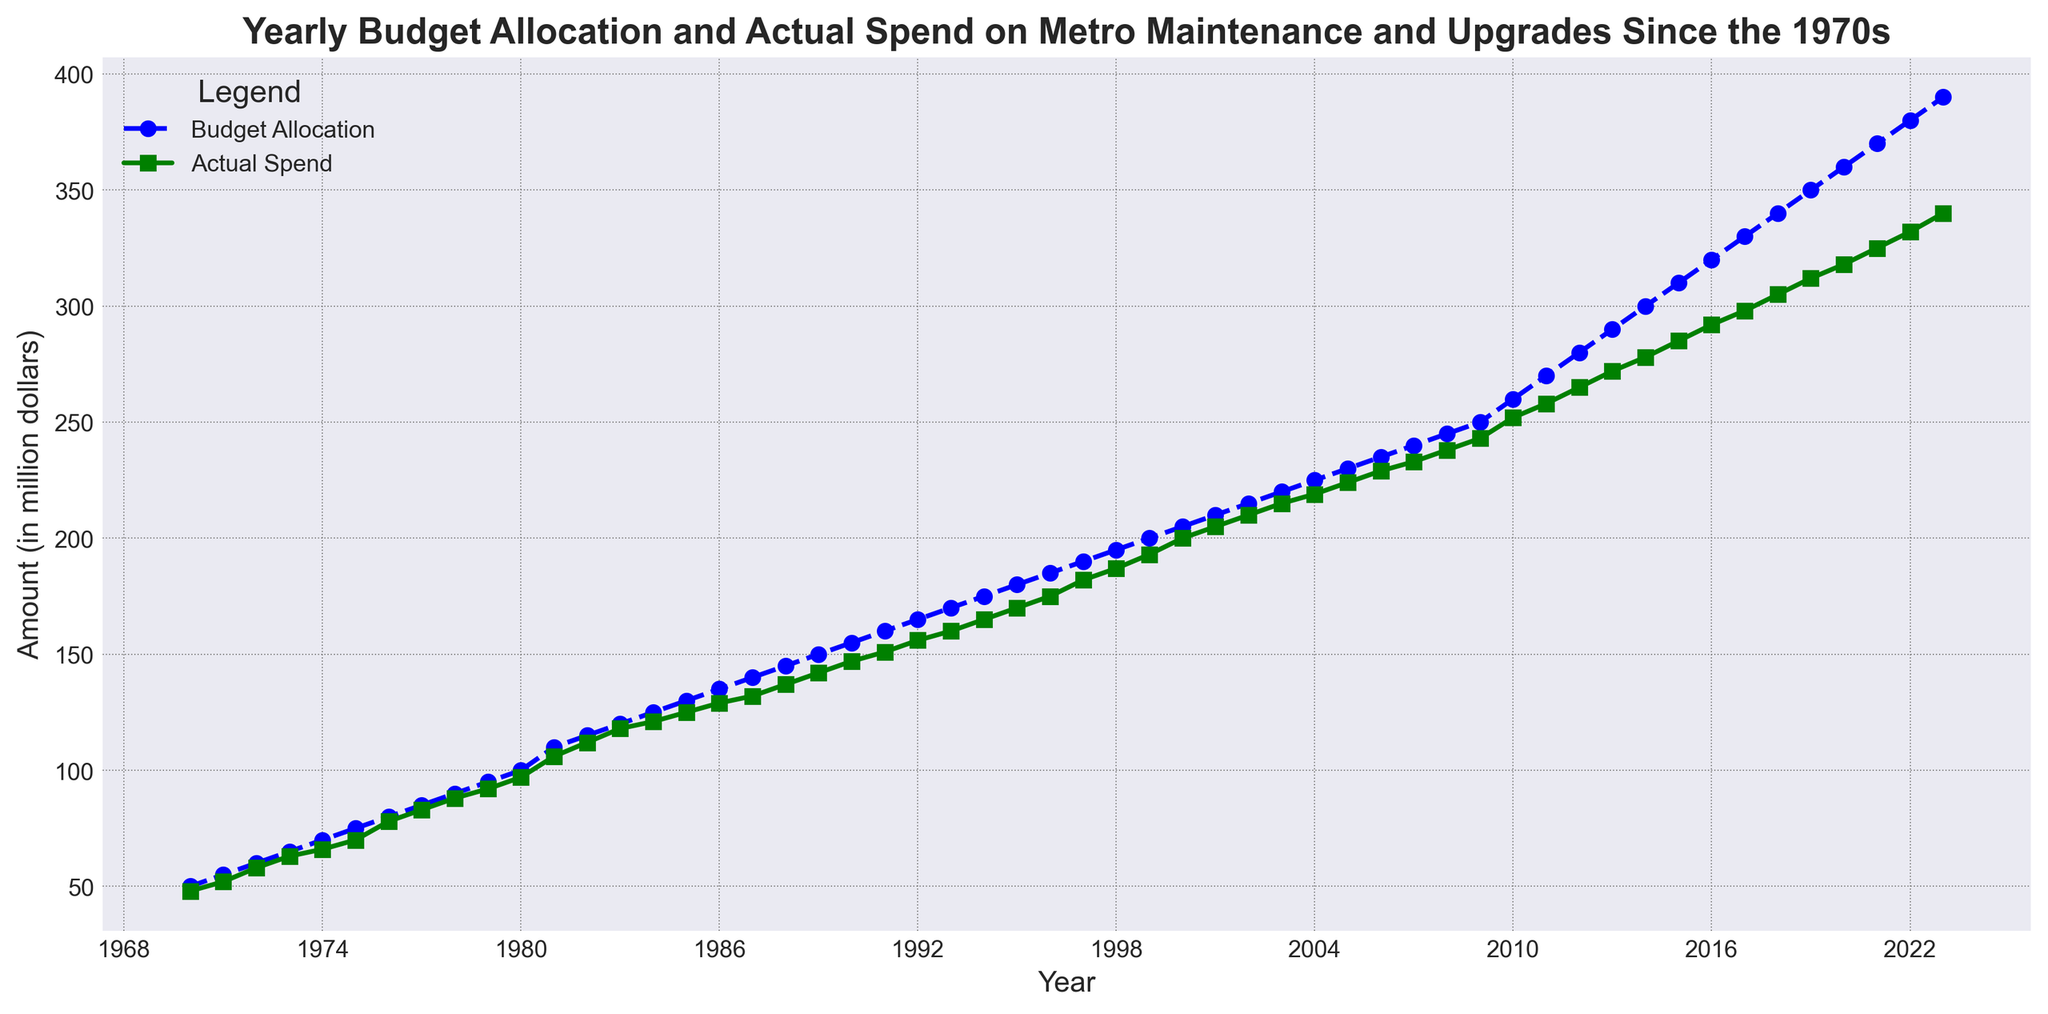What is the trend of Budget Allocation from 1970 to 2023? The Budget Allocation shows a steady increasing trend from 50 million dollars in 1970 to 390 million dollars in 2023.
Answer: Increasing How often did the Actual Spend exceed the Budget Allocation? By observing the lines on the plot, we can see that the Actual Spend consistently falls below the Budget Allocation throughout the entire period from 1970 to 2023.
Answer: Never What is the difference between Budget Allocation and Actual Spend in 1980? From the figure, the Budget Allocation in 1980 is 100 million dollars, and the Actual Spend is 97 million dollars. The difference is 100 - 97.
Answer: 3 million dollars Which year had the largest gap between Budget Allocation and Actual Spend? By visually inspecting the gap between the two curves, 2023 shows the largest gap. The Budget Allocation in 2023 is 390 million dollars, and Actual Spend is 340 million dollars. The difference is 390 - 340.
Answer: 2023 What is the average Actual Spend between 2000 and 2010? Add the Actual Spend from 2000 to 2010: (200 + 205 + 210 + 215 + 219 + 224 + 229 + 233 + 238 + 243 + 252), which equals 2268, then divide by the number of years, which is 11.
Answer: 206.18 million dollars How does the rate of increase in Actual Spend compare to Budget Allocation from 2015 to 2020? To compare the rates:
Rate of increase for Budget Allocation: (360 - 310) / 310 = 0.161, or 16.1%
Rate of increase for Actual Spend: (318 - 285) / 285 = 0.1158, or 11.58% 
Hence, the Budget Allocation has a higher rate of increase than Actual Spend.
Answer: Budget Allocation increases faster By how much did the Budget Allocation increase from the year 1990 to the year 2000? The Budget Allocation in 1990 is 155 million dollars, and in 2000 it is 205 million dollars. The increase is 205 - 155.
Answer: 50 million dollars Which had a more significant increase from the beginning to the end of the period, Budget Allocation or Actual Spend? Budget Allocation increased from 50 million dollars in 1970 to 390 million dollars in 2023, amounting to an increase of 340 million dollars.
Actual Spend increased from 48 million dollars in 1970 to 340 million dollars in 2023, amounting to an increase of 292 million dollars. Hence, Budget Allocation had a more significant increase.
Answer: Budget Allocation 